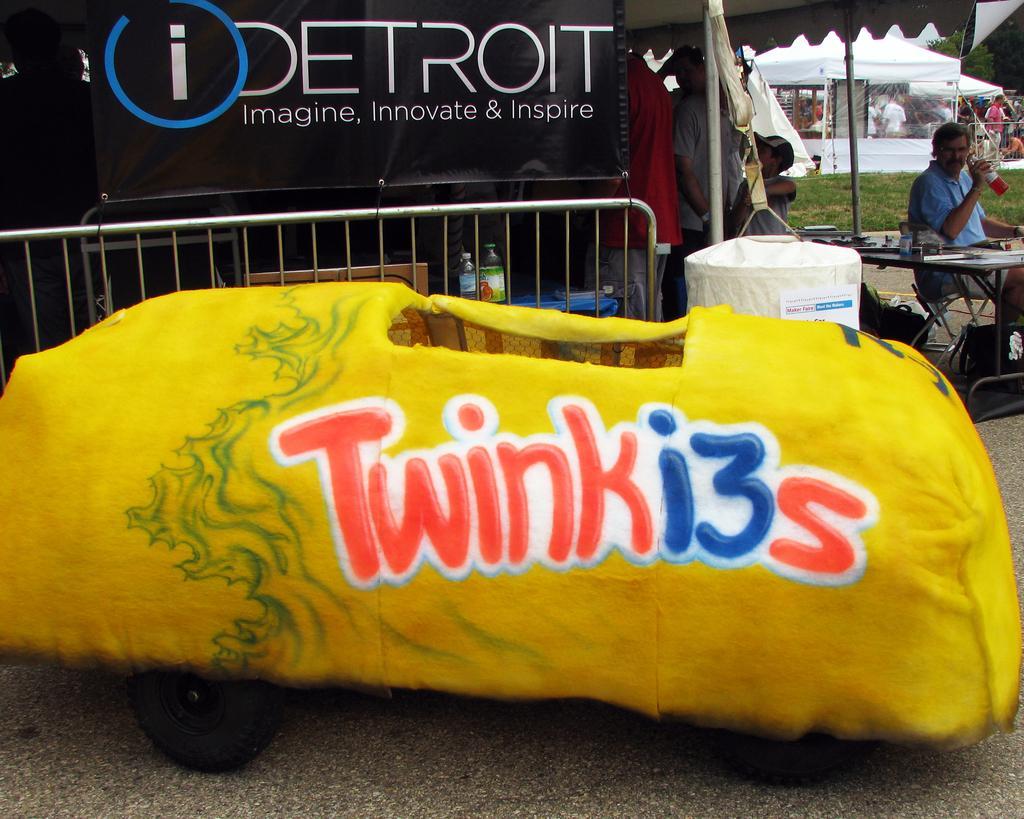Please provide a concise description of this image. Here I can see an object which is covered with a yellow color cloth. Under this I can see the wheels. It seems to be a vehicle. Behind there is a railing and a board. At the top of the image I can see few people under the tents and also I can see the grass on the ground. 